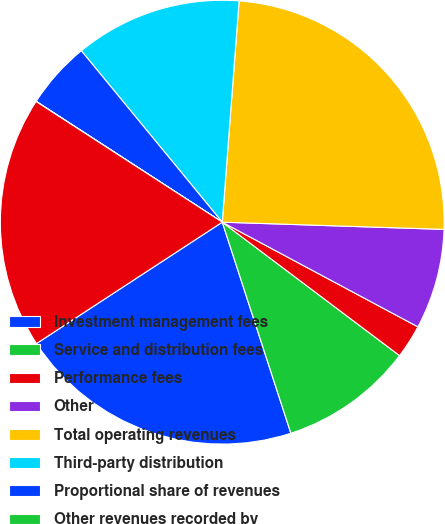Convert chart to OTSL. <chart><loc_0><loc_0><loc_500><loc_500><pie_chart><fcel>Investment management fees<fcel>Service and distribution fees<fcel>Performance fees<fcel>Other<fcel>Total operating revenues<fcel>Third-party distribution<fcel>Proportional share of revenues<fcel>Other revenues recorded by<fcel>Net revenues<nl><fcel>20.79%<fcel>9.73%<fcel>2.45%<fcel>7.3%<fcel>24.31%<fcel>12.16%<fcel>4.88%<fcel>0.02%<fcel>18.36%<nl></chart> 